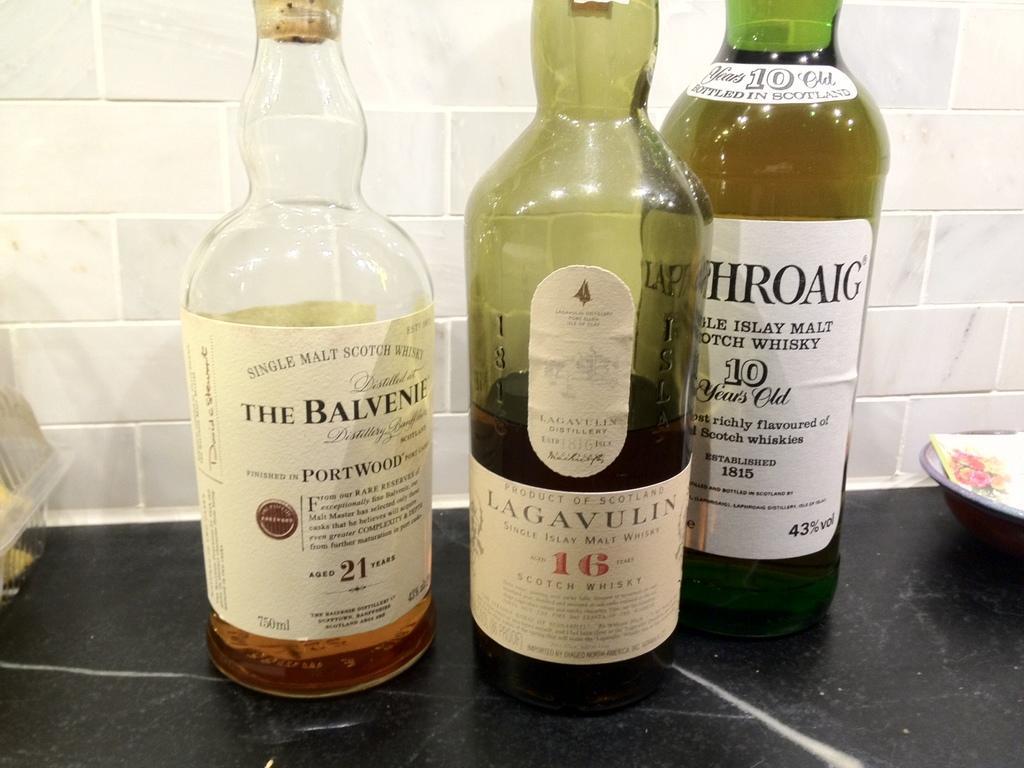Please provide a concise description of this image. In the image there is a table, on table we can see three bottles on which it is labelled as 'THE BALVENIE'. On right side there is a bowl, in background we can see a white color wall. 